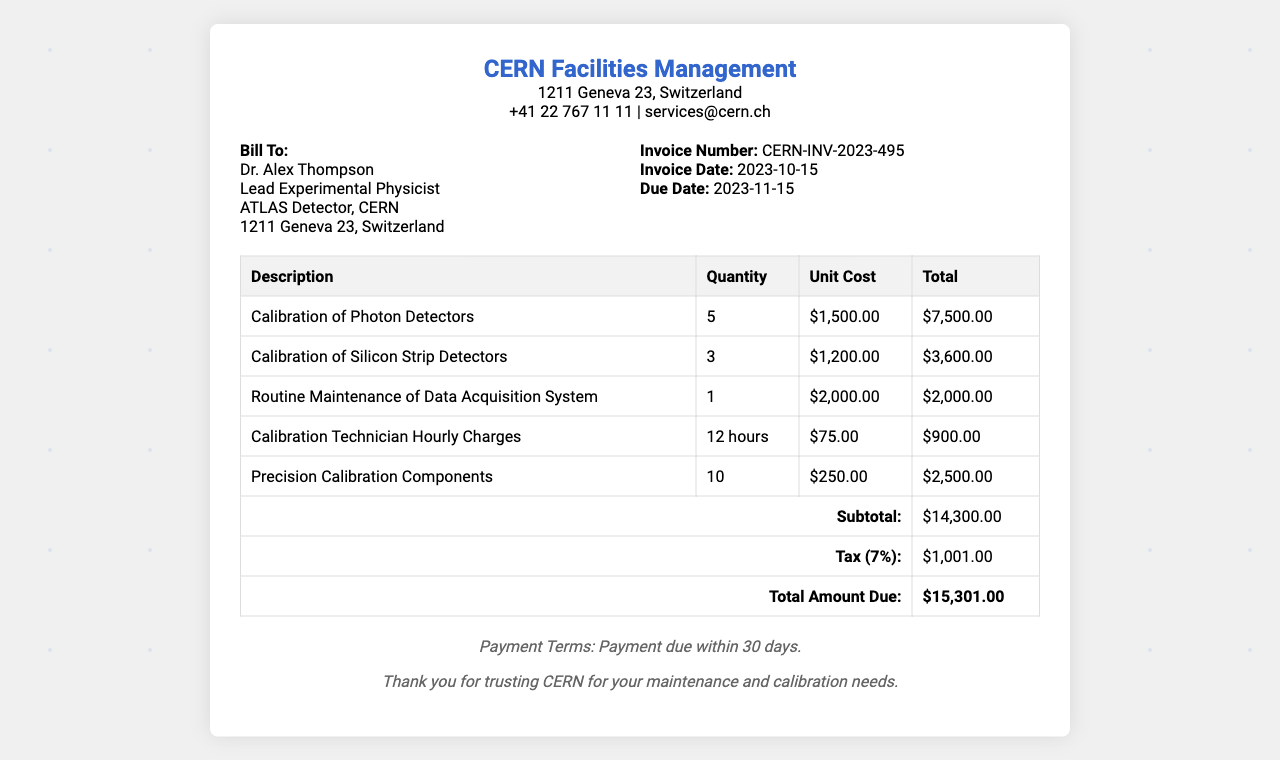What is the invoice number? The invoice number is listed prominently in the document, which helps identify the transaction.
Answer: CERN-INV-2023-495 What is the total amount due? The total amount due is the final charge after calculating labor, parts, and tax, presented at the end of the invoice.
Answer: $15,301.00 Who is the bill recipient? The bill recipient is mentioned at the beginning of the invoice, indicating to whom the services were billed.
Answer: Dr. Alex Thompson When is the invoice date? The invoice date is specified in the details section, indicating when the services were billed.
Answer: 2023-10-15 What service had the highest unit cost? This question analyzes the cost breakdown to determine which service was the most expensive based on the unit cost.
Answer: Calibration of Photon Detectors How many calibration technician hours were billed? This question pertains to the labor portion of the invoice, allowing for assessment of labor services rendered.
Answer: 12 hours What is the tax percentage applied to the invoice? The tax percentage shows the governing tax rate applicable to the invoice's subtotal, impacting the overall total.
Answer: 7% What is the subtotal before tax? Understanding the subtotal allows one to see the total cost of services before any tax is applied.
Answer: $14,300.00 What maintenance service was provided for routine maintenance? Identifying provided services helps in understanding the scope of maintenance performed.
Answer: Routine Maintenance of Data Acquisition System 